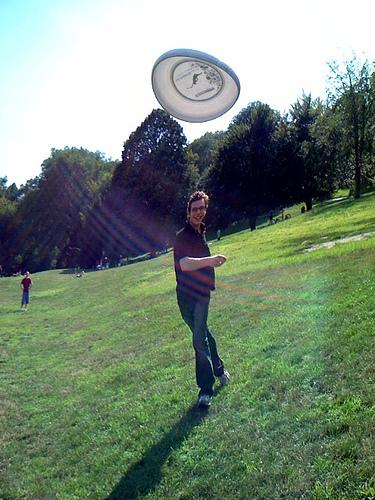Is the frisbee airborne?
Concise answer only. Yes. Is he throwing or catching the frisbee?
Short answer required. Throwing. Is this a sunny day?
Quick response, please. Yes. 